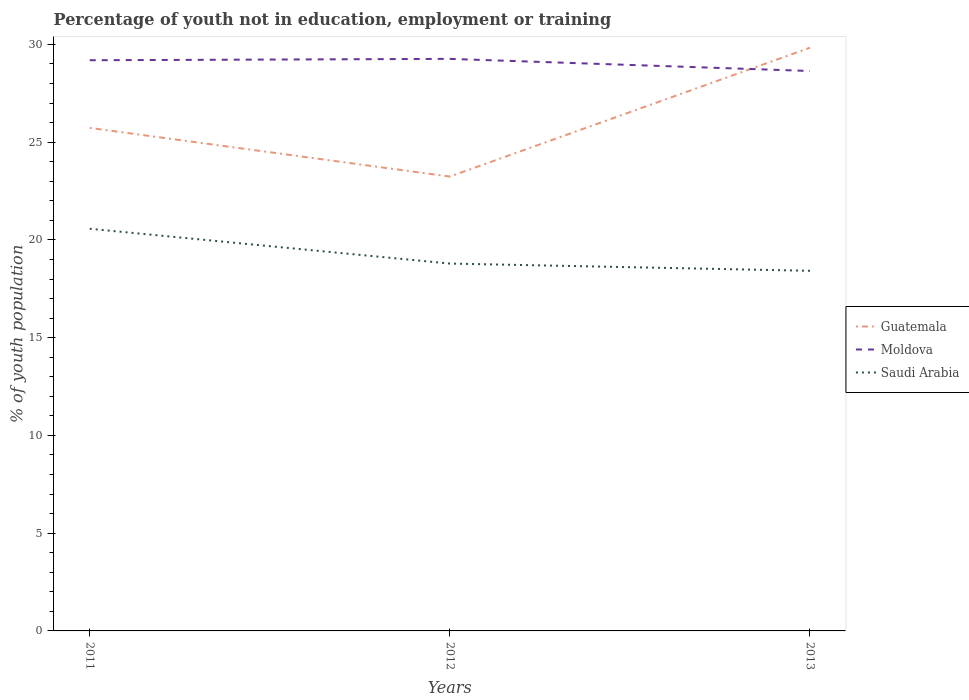How many different coloured lines are there?
Your answer should be compact. 3. Does the line corresponding to Saudi Arabia intersect with the line corresponding to Moldova?
Your answer should be very brief. No. Across all years, what is the maximum percentage of unemployed youth population in in Guatemala?
Provide a short and direct response. 23.24. What is the total percentage of unemployed youth population in in Moldova in the graph?
Provide a short and direct response. -0.07. What is the difference between the highest and the second highest percentage of unemployed youth population in in Saudi Arabia?
Make the answer very short. 2.15. How many lines are there?
Offer a very short reply. 3. How many years are there in the graph?
Your response must be concise. 3. Does the graph contain any zero values?
Give a very brief answer. No. How many legend labels are there?
Ensure brevity in your answer.  3. What is the title of the graph?
Provide a short and direct response. Percentage of youth not in education, employment or training. What is the label or title of the Y-axis?
Give a very brief answer. % of youth population. What is the % of youth population in Guatemala in 2011?
Your response must be concise. 25.73. What is the % of youth population in Moldova in 2011?
Give a very brief answer. 29.19. What is the % of youth population of Saudi Arabia in 2011?
Keep it short and to the point. 20.57. What is the % of youth population in Guatemala in 2012?
Your answer should be very brief. 23.24. What is the % of youth population in Moldova in 2012?
Ensure brevity in your answer.  29.26. What is the % of youth population in Saudi Arabia in 2012?
Provide a short and direct response. 18.79. What is the % of youth population in Guatemala in 2013?
Make the answer very short. 29.83. What is the % of youth population of Moldova in 2013?
Make the answer very short. 28.64. What is the % of youth population of Saudi Arabia in 2013?
Your answer should be very brief. 18.42. Across all years, what is the maximum % of youth population of Guatemala?
Offer a terse response. 29.83. Across all years, what is the maximum % of youth population of Moldova?
Offer a very short reply. 29.26. Across all years, what is the maximum % of youth population of Saudi Arabia?
Give a very brief answer. 20.57. Across all years, what is the minimum % of youth population of Guatemala?
Provide a short and direct response. 23.24. Across all years, what is the minimum % of youth population in Moldova?
Make the answer very short. 28.64. Across all years, what is the minimum % of youth population in Saudi Arabia?
Your answer should be very brief. 18.42. What is the total % of youth population of Guatemala in the graph?
Provide a short and direct response. 78.8. What is the total % of youth population of Moldova in the graph?
Your response must be concise. 87.09. What is the total % of youth population of Saudi Arabia in the graph?
Keep it short and to the point. 57.78. What is the difference between the % of youth population of Guatemala in 2011 and that in 2012?
Provide a short and direct response. 2.49. What is the difference between the % of youth population in Moldova in 2011 and that in 2012?
Provide a short and direct response. -0.07. What is the difference between the % of youth population of Saudi Arabia in 2011 and that in 2012?
Your answer should be compact. 1.78. What is the difference between the % of youth population in Guatemala in 2011 and that in 2013?
Give a very brief answer. -4.1. What is the difference between the % of youth population of Moldova in 2011 and that in 2013?
Give a very brief answer. 0.55. What is the difference between the % of youth population in Saudi Arabia in 2011 and that in 2013?
Make the answer very short. 2.15. What is the difference between the % of youth population of Guatemala in 2012 and that in 2013?
Provide a short and direct response. -6.59. What is the difference between the % of youth population of Moldova in 2012 and that in 2013?
Your answer should be compact. 0.62. What is the difference between the % of youth population of Saudi Arabia in 2012 and that in 2013?
Keep it short and to the point. 0.37. What is the difference between the % of youth population of Guatemala in 2011 and the % of youth population of Moldova in 2012?
Your response must be concise. -3.53. What is the difference between the % of youth population in Guatemala in 2011 and the % of youth population in Saudi Arabia in 2012?
Give a very brief answer. 6.94. What is the difference between the % of youth population of Guatemala in 2011 and the % of youth population of Moldova in 2013?
Provide a short and direct response. -2.91. What is the difference between the % of youth population in Guatemala in 2011 and the % of youth population in Saudi Arabia in 2013?
Keep it short and to the point. 7.31. What is the difference between the % of youth population of Moldova in 2011 and the % of youth population of Saudi Arabia in 2013?
Give a very brief answer. 10.77. What is the difference between the % of youth population of Guatemala in 2012 and the % of youth population of Moldova in 2013?
Offer a terse response. -5.4. What is the difference between the % of youth population of Guatemala in 2012 and the % of youth population of Saudi Arabia in 2013?
Give a very brief answer. 4.82. What is the difference between the % of youth population of Moldova in 2012 and the % of youth population of Saudi Arabia in 2013?
Your answer should be compact. 10.84. What is the average % of youth population in Guatemala per year?
Provide a succinct answer. 26.27. What is the average % of youth population in Moldova per year?
Your answer should be compact. 29.03. What is the average % of youth population of Saudi Arabia per year?
Give a very brief answer. 19.26. In the year 2011, what is the difference between the % of youth population of Guatemala and % of youth population of Moldova?
Offer a terse response. -3.46. In the year 2011, what is the difference between the % of youth population in Guatemala and % of youth population in Saudi Arabia?
Offer a terse response. 5.16. In the year 2011, what is the difference between the % of youth population in Moldova and % of youth population in Saudi Arabia?
Provide a succinct answer. 8.62. In the year 2012, what is the difference between the % of youth population in Guatemala and % of youth population in Moldova?
Keep it short and to the point. -6.02. In the year 2012, what is the difference between the % of youth population of Guatemala and % of youth population of Saudi Arabia?
Give a very brief answer. 4.45. In the year 2012, what is the difference between the % of youth population in Moldova and % of youth population in Saudi Arabia?
Your answer should be very brief. 10.47. In the year 2013, what is the difference between the % of youth population in Guatemala and % of youth population in Moldova?
Give a very brief answer. 1.19. In the year 2013, what is the difference between the % of youth population of Guatemala and % of youth population of Saudi Arabia?
Provide a succinct answer. 11.41. In the year 2013, what is the difference between the % of youth population in Moldova and % of youth population in Saudi Arabia?
Offer a terse response. 10.22. What is the ratio of the % of youth population of Guatemala in 2011 to that in 2012?
Your answer should be very brief. 1.11. What is the ratio of the % of youth population of Saudi Arabia in 2011 to that in 2012?
Your response must be concise. 1.09. What is the ratio of the % of youth population in Guatemala in 2011 to that in 2013?
Give a very brief answer. 0.86. What is the ratio of the % of youth population in Moldova in 2011 to that in 2013?
Offer a very short reply. 1.02. What is the ratio of the % of youth population in Saudi Arabia in 2011 to that in 2013?
Provide a short and direct response. 1.12. What is the ratio of the % of youth population of Guatemala in 2012 to that in 2013?
Provide a succinct answer. 0.78. What is the ratio of the % of youth population in Moldova in 2012 to that in 2013?
Provide a succinct answer. 1.02. What is the ratio of the % of youth population in Saudi Arabia in 2012 to that in 2013?
Keep it short and to the point. 1.02. What is the difference between the highest and the second highest % of youth population in Guatemala?
Provide a succinct answer. 4.1. What is the difference between the highest and the second highest % of youth population of Moldova?
Ensure brevity in your answer.  0.07. What is the difference between the highest and the second highest % of youth population of Saudi Arabia?
Offer a terse response. 1.78. What is the difference between the highest and the lowest % of youth population of Guatemala?
Your answer should be very brief. 6.59. What is the difference between the highest and the lowest % of youth population in Moldova?
Make the answer very short. 0.62. What is the difference between the highest and the lowest % of youth population in Saudi Arabia?
Your response must be concise. 2.15. 